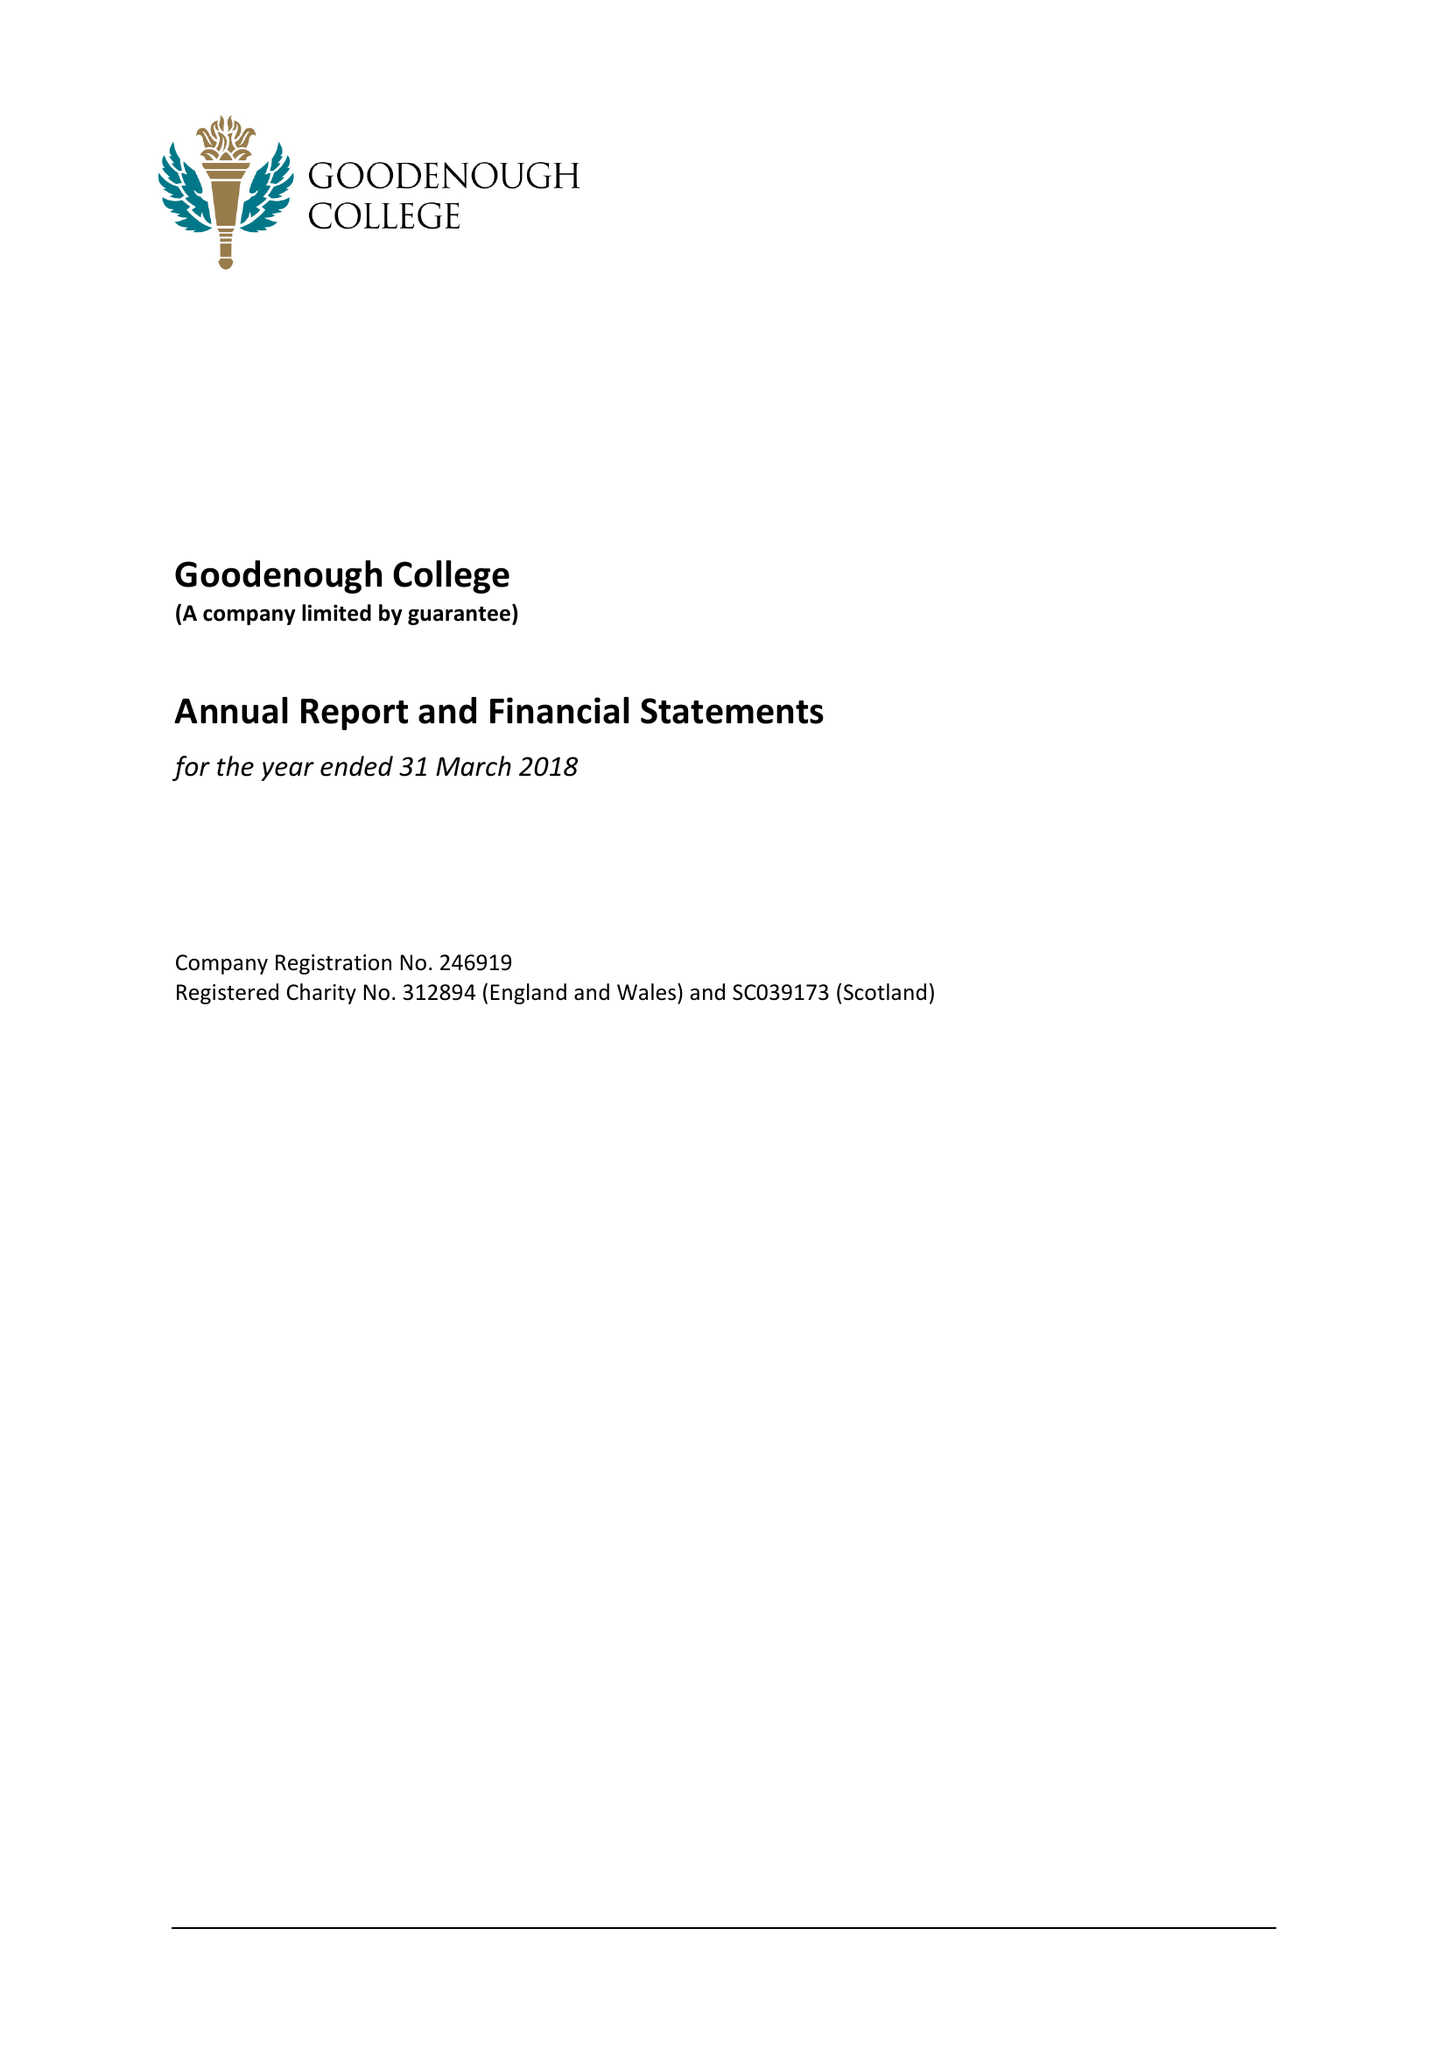What is the value for the charity_number?
Answer the question using a single word or phrase. 312894 